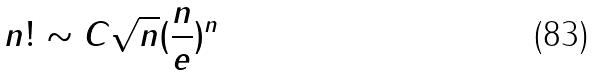Convert formula to latex. <formula><loc_0><loc_0><loc_500><loc_500>n ! \sim C \sqrt { n } ( \frac { n } { e } ) ^ { n }</formula> 